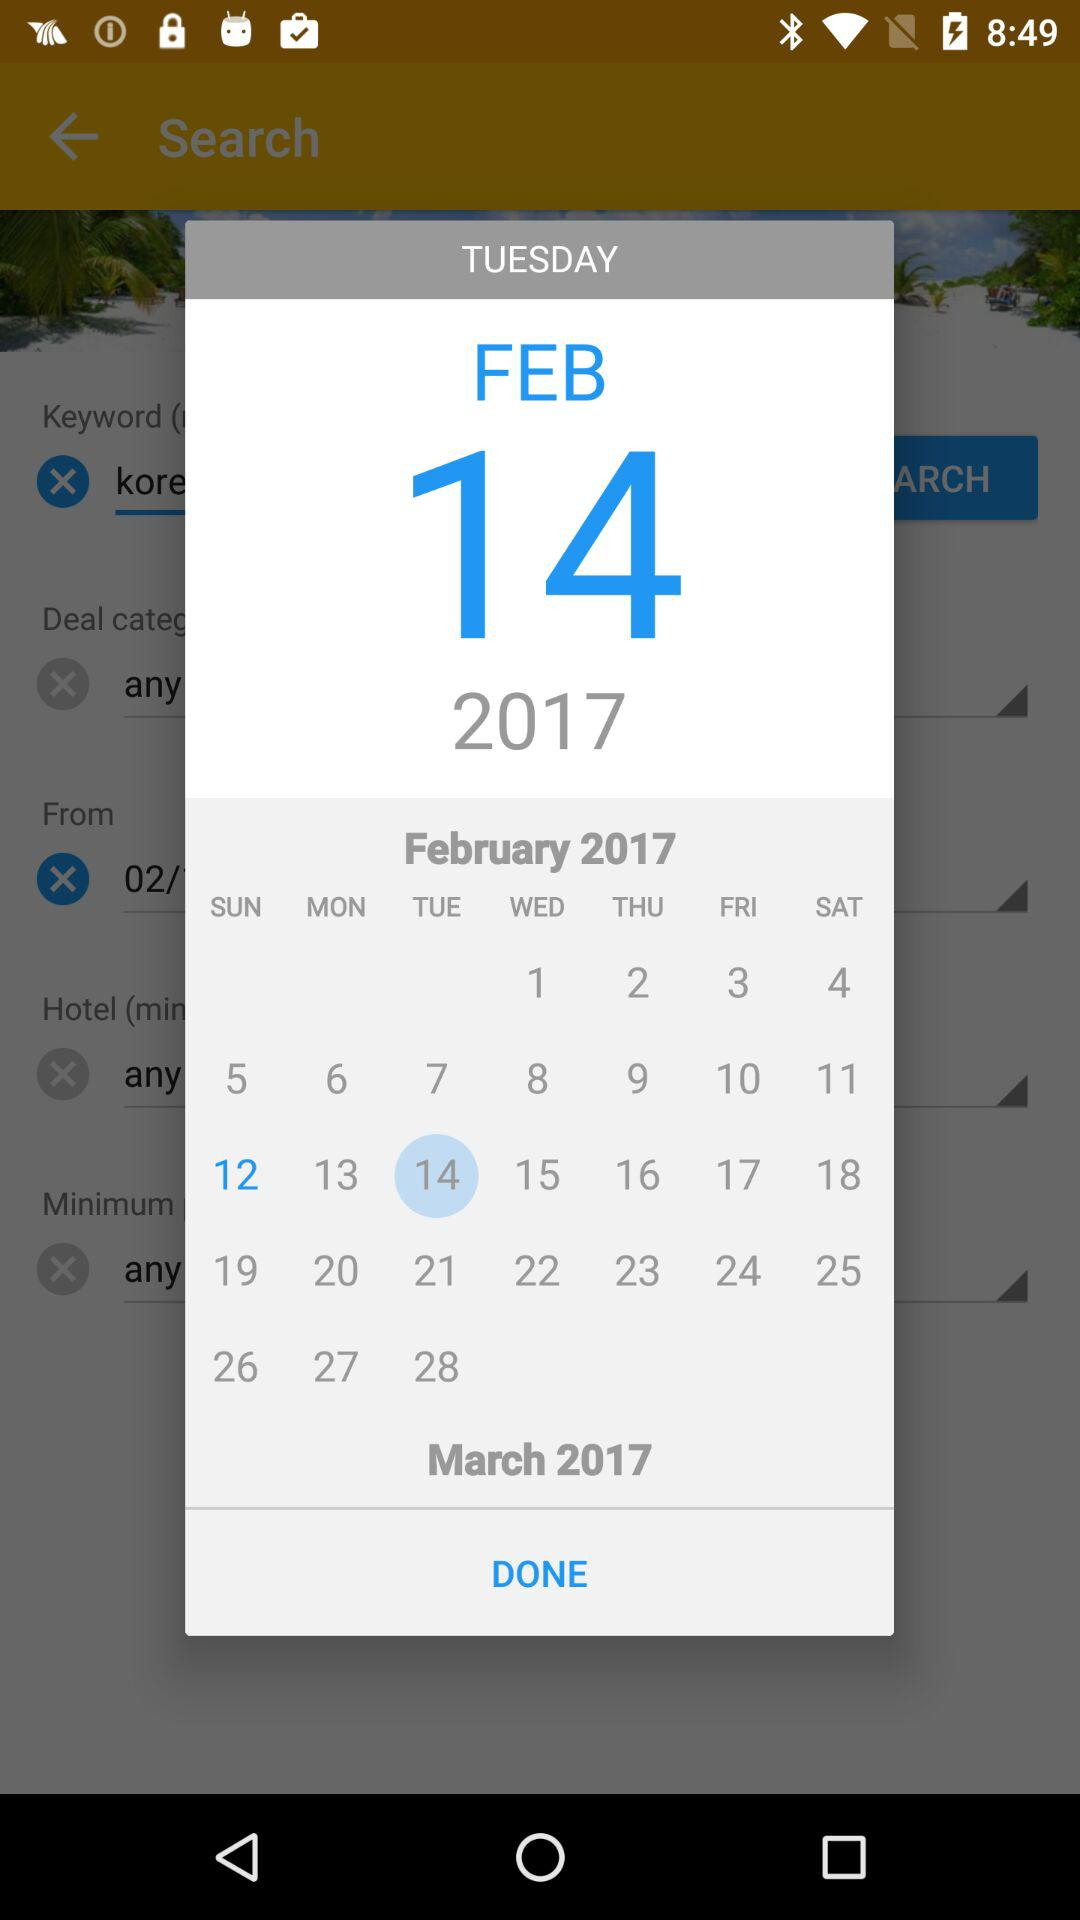Which day is February 14 on the calendar? The day is Tuesday. 